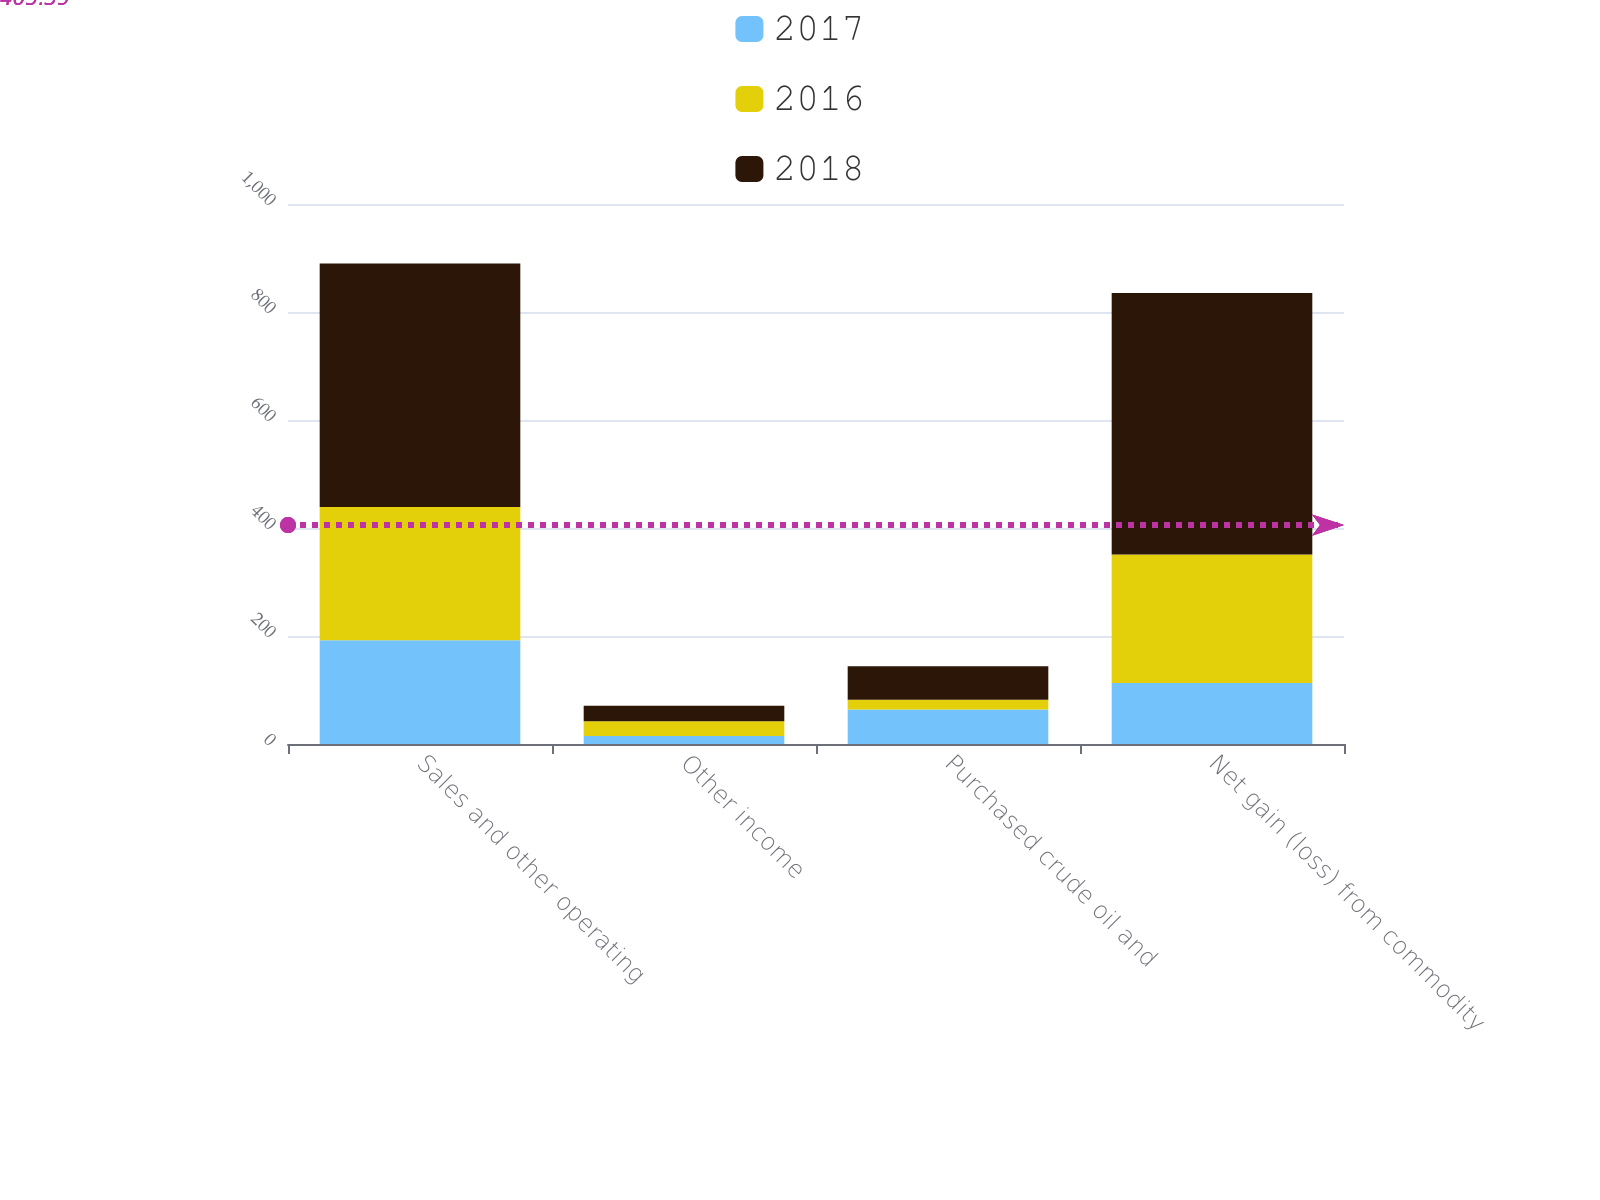<chart> <loc_0><loc_0><loc_500><loc_500><stacked_bar_chart><ecel><fcel>Sales and other operating<fcel>Other income<fcel>Purchased crude oil and<fcel>Net gain (loss) from commodity<nl><fcel>2017<fcel>192<fcel>15<fcel>64<fcel>113<nl><fcel>2016<fcel>247<fcel>27<fcel>18<fcel>238<nl><fcel>2018<fcel>451<fcel>29<fcel>62<fcel>484<nl></chart> 